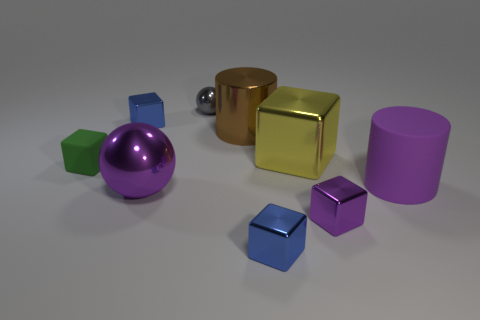Is the shape of the tiny green matte object the same as the yellow object?
Your answer should be very brief. Yes. What number of purple objects are in front of the large metallic thing in front of the small green object?
Your answer should be compact. 1. What is the material of the other object that is the same shape as the purple matte object?
Ensure brevity in your answer.  Metal. Is the color of the big cylinder in front of the tiny rubber thing the same as the matte cube?
Offer a terse response. No. Are the green object and the tiny gray thing that is left of the large yellow metallic cube made of the same material?
Your response must be concise. No. The large thing that is in front of the large rubber object has what shape?
Offer a terse response. Sphere. How many other things are made of the same material as the brown cylinder?
Provide a short and direct response. 6. What is the size of the purple cylinder?
Make the answer very short. Large. What number of other objects are the same color as the tiny metal ball?
Provide a short and direct response. 0. There is a tiny cube that is both behind the large purple shiny object and right of the green thing; what color is it?
Ensure brevity in your answer.  Blue. 